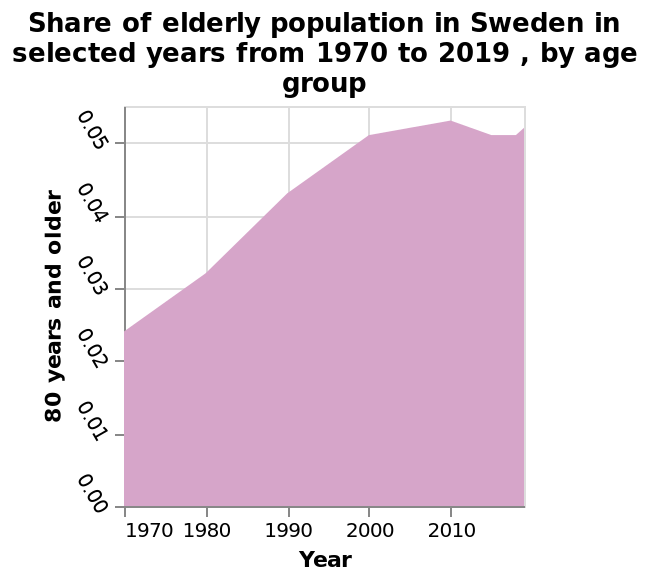<image>
Did the share of elderly population increase or decrease between 1970 and 2010?  The share of elderly population increased between 1970 and 2010. Did the share of elderly population decrease or remain constant after 2010?  The share of elderly population decreased after 2010. In what range does the data on the y-axis lie? The data on the y-axis lies between 0% and 100%. What does the x-axis represent in the graph?  The x-axis represents the years from 1970 to 2019. Did the share of elderly population decrease between 1970 and 2010? No. The share of elderly population increased between 1970 and 2010. 